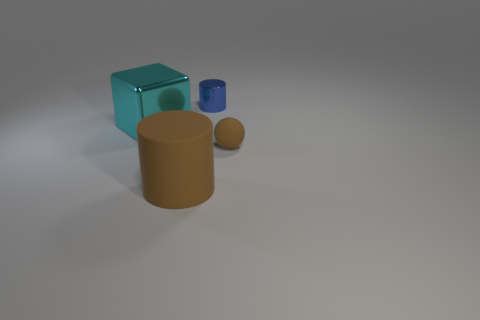Add 1 tiny brown spheres. How many objects exist? 5 Subtract all cubes. How many objects are left? 3 Add 4 large metal cylinders. How many large metal cylinders exist? 4 Subtract 0 purple cubes. How many objects are left? 4 Subtract all brown balls. Subtract all tiny blue shiny objects. How many objects are left? 2 Add 3 large cyan objects. How many large cyan objects are left? 4 